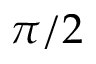Convert formula to latex. <formula><loc_0><loc_0><loc_500><loc_500>\pi / 2</formula> 